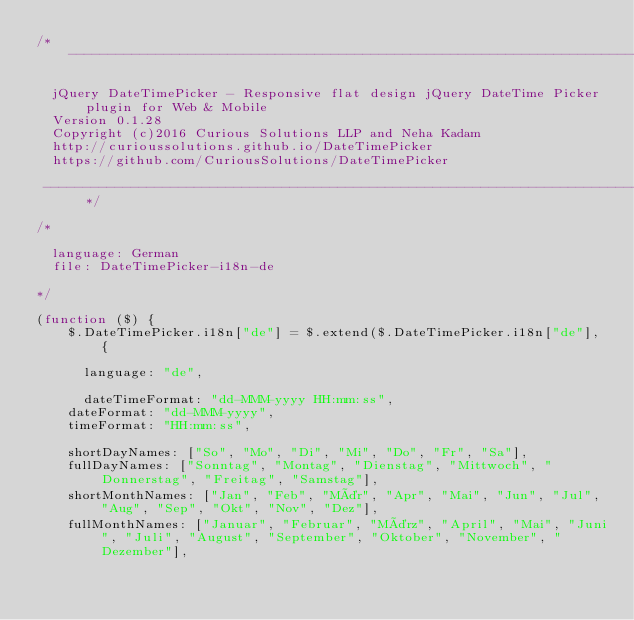<code> <loc_0><loc_0><loc_500><loc_500><_JavaScript_>/* ----------------------------------------------------------------------------- 

  jQuery DateTimePicker - Responsive flat design jQuery DateTime Picker plugin for Web & Mobile
  Version 0.1.28
  Copyright (c)2016 Curious Solutions LLP and Neha Kadam
  http://curioussolutions.github.io/DateTimePicker
  https://github.com/CuriousSolutions/DateTimePicker

 ----------------------------------------------------------------------------- */

/*

	language: German
	file: DateTimePicker-i18n-de

*/

(function ($) {
    $.DateTimePicker.i18n["de"] = $.extend($.DateTimePicker.i18n["de"], {
        
    	language: "de",

    	dateTimeFormat: "dd-MMM-yyyy HH:mm:ss",
		dateFormat: "dd-MMM-yyyy",
		timeFormat: "HH:mm:ss",

		shortDayNames: ["So", "Mo", "Di", "Mi", "Do", "Fr", "Sa"],
		fullDayNames: ["Sonntag", "Montag", "Dienstag", "Mittwoch", "Donnerstag", "Freitag", "Samstag"],
		shortMonthNames: ["Jan", "Feb", "Mär", "Apr", "Mai", "Jun", "Jul", "Aug", "Sep", "Okt", "Nov", "Dez"],
		fullMonthNames: ["Januar", "Februar", "März", "April", "Mai", "Juni", "Juli", "August", "September", "Oktober", "November", "Dezember"],
</code> 